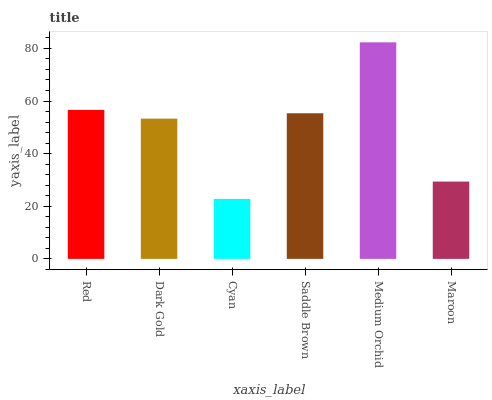Is Cyan the minimum?
Answer yes or no. Yes. Is Medium Orchid the maximum?
Answer yes or no. Yes. Is Dark Gold the minimum?
Answer yes or no. No. Is Dark Gold the maximum?
Answer yes or no. No. Is Red greater than Dark Gold?
Answer yes or no. Yes. Is Dark Gold less than Red?
Answer yes or no. Yes. Is Dark Gold greater than Red?
Answer yes or no. No. Is Red less than Dark Gold?
Answer yes or no. No. Is Saddle Brown the high median?
Answer yes or no. Yes. Is Dark Gold the low median?
Answer yes or no. Yes. Is Red the high median?
Answer yes or no. No. Is Cyan the low median?
Answer yes or no. No. 